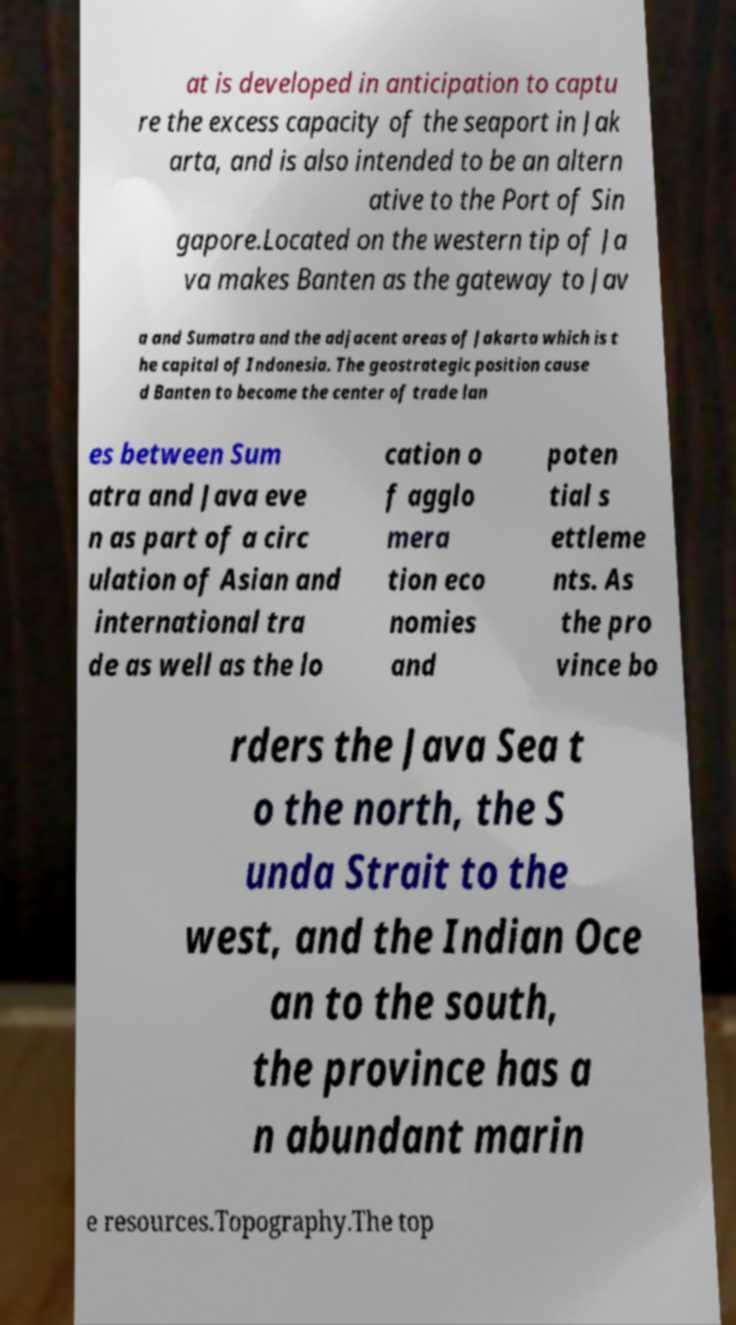For documentation purposes, I need the text within this image transcribed. Could you provide that? at is developed in anticipation to captu re the excess capacity of the seaport in Jak arta, and is also intended to be an altern ative to the Port of Sin gapore.Located on the western tip of Ja va makes Banten as the gateway to Jav a and Sumatra and the adjacent areas of Jakarta which is t he capital of Indonesia. The geostrategic position cause d Banten to become the center of trade lan es between Sum atra and Java eve n as part of a circ ulation of Asian and international tra de as well as the lo cation o f agglo mera tion eco nomies and poten tial s ettleme nts. As the pro vince bo rders the Java Sea t o the north, the S unda Strait to the west, and the Indian Oce an to the south, the province has a n abundant marin e resources.Topography.The top 